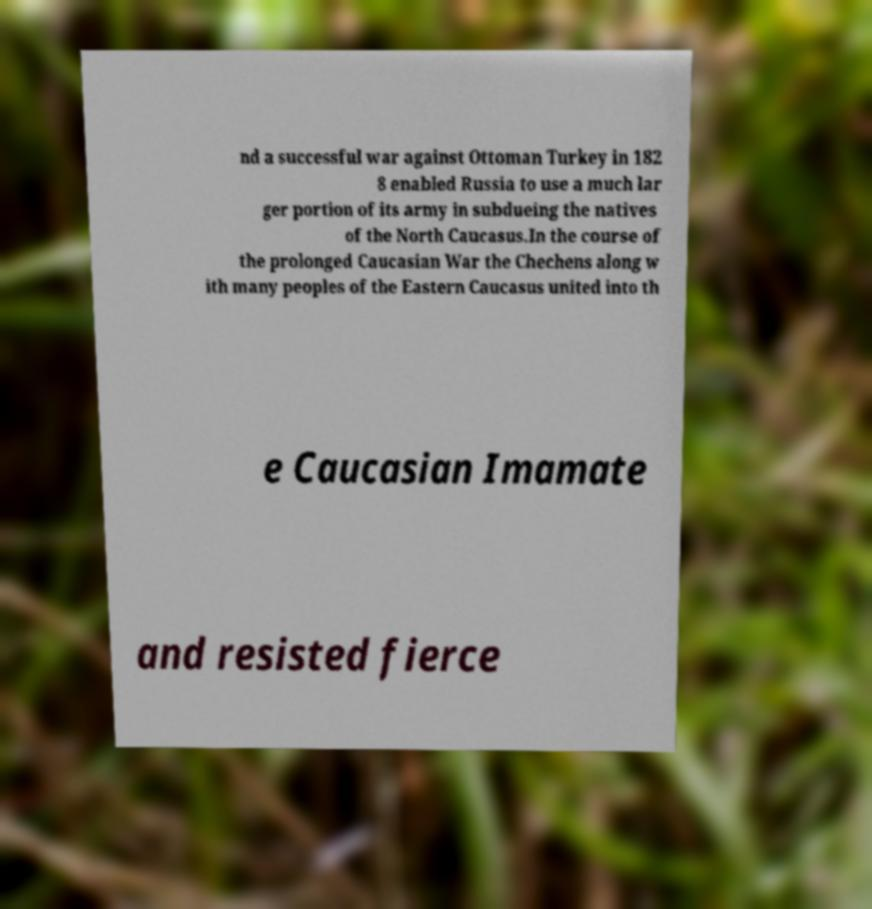Can you read and provide the text displayed in the image?This photo seems to have some interesting text. Can you extract and type it out for me? nd a successful war against Ottoman Turkey in 182 8 enabled Russia to use a much lar ger portion of its army in subdueing the natives of the North Caucasus.In the course of the prolonged Caucasian War the Chechens along w ith many peoples of the Eastern Caucasus united into th e Caucasian Imamate and resisted fierce 